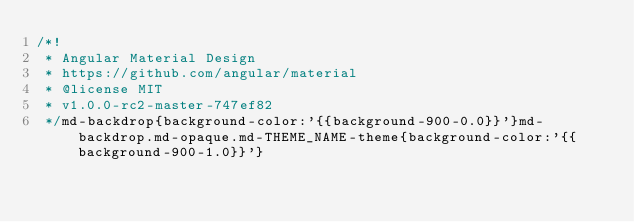<code> <loc_0><loc_0><loc_500><loc_500><_CSS_>/*!
 * Angular Material Design
 * https://github.com/angular/material
 * @license MIT
 * v1.0.0-rc2-master-747ef82
 */md-backdrop{background-color:'{{background-900-0.0}}'}md-backdrop.md-opaque.md-THEME_NAME-theme{background-color:'{{background-900-1.0}}'}</code> 